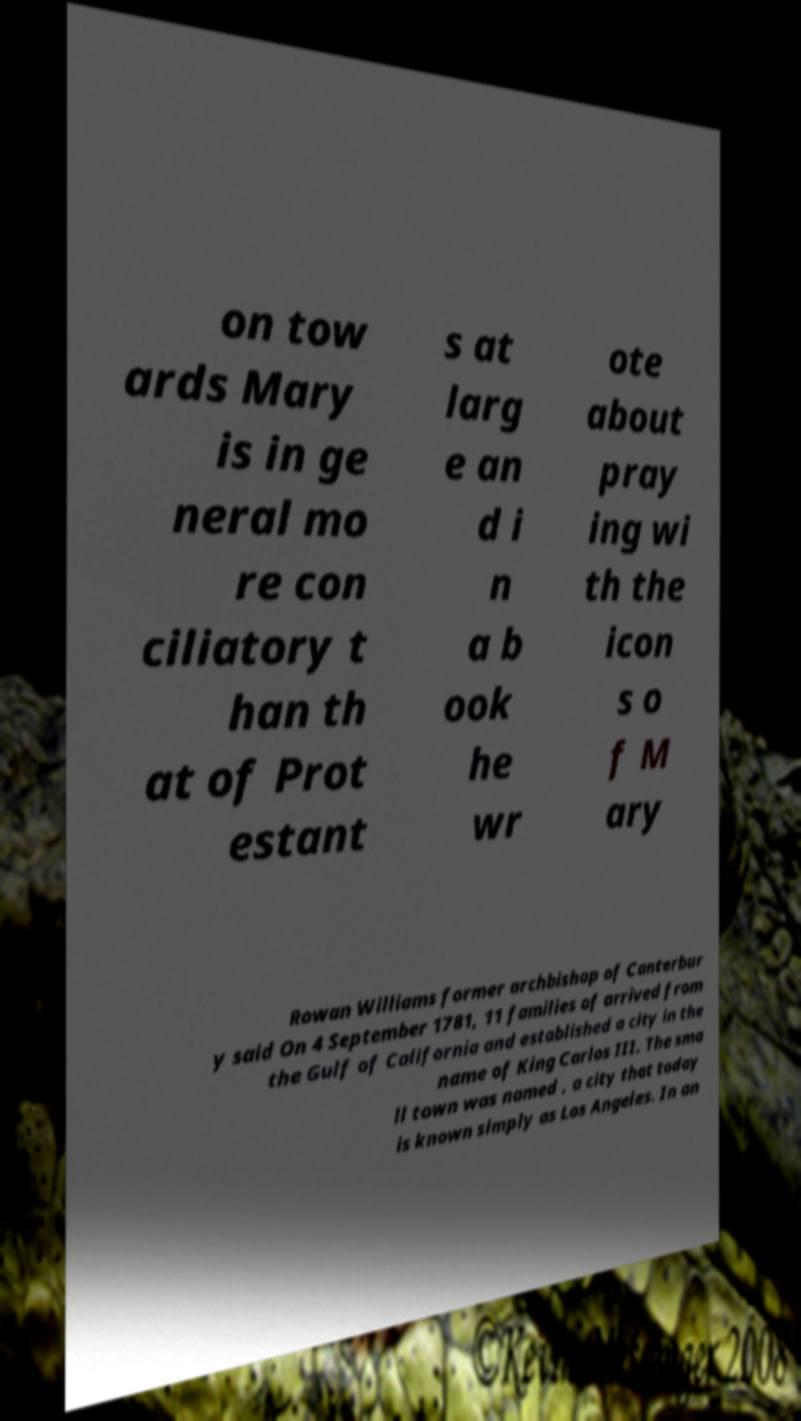I need the written content from this picture converted into text. Can you do that? on tow ards Mary is in ge neral mo re con ciliatory t han th at of Prot estant s at larg e an d i n a b ook he wr ote about pray ing wi th the icon s o f M ary Rowan Williams former archbishop of Canterbur y said On 4 September 1781, 11 families of arrived from the Gulf of California and established a city in the name of King Carlos III. The sma ll town was named , a city that today is known simply as Los Angeles. In an 